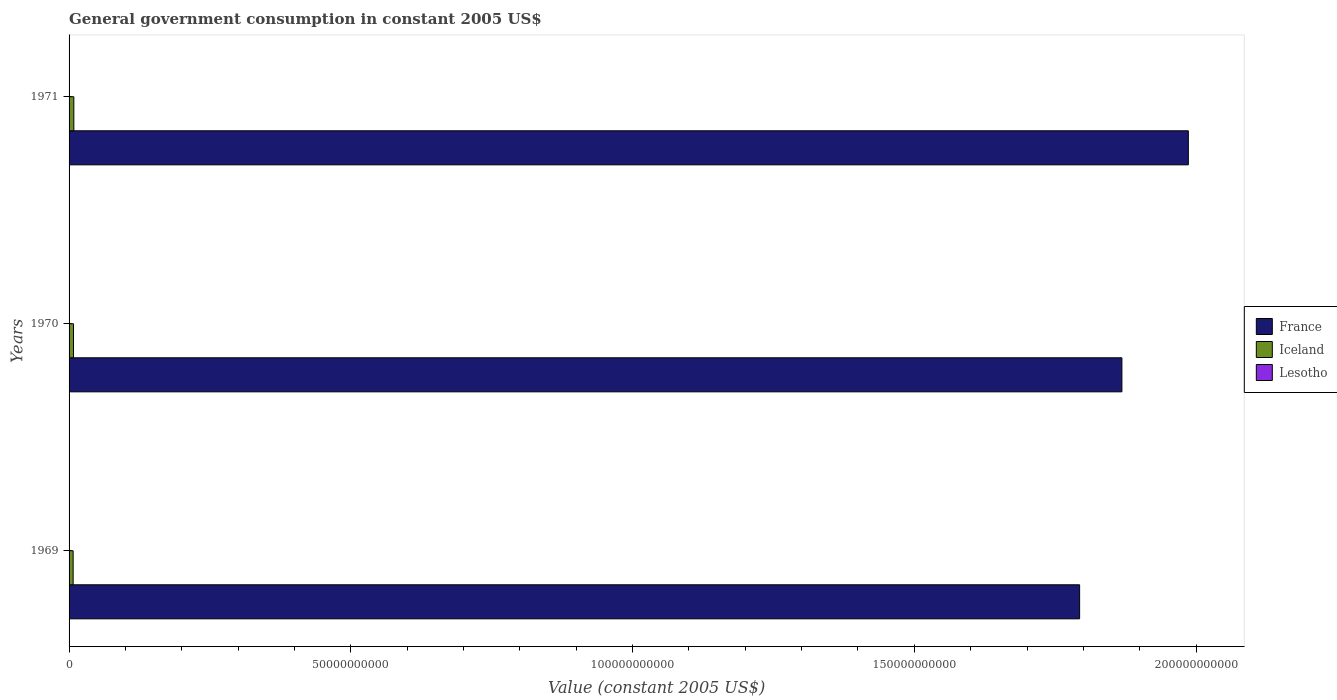How many different coloured bars are there?
Provide a succinct answer. 3. How many groups of bars are there?
Provide a short and direct response. 3. Are the number of bars on each tick of the Y-axis equal?
Provide a succinct answer. Yes. How many bars are there on the 3rd tick from the top?
Your answer should be very brief. 3. How many bars are there on the 3rd tick from the bottom?
Offer a very short reply. 3. What is the government conusmption in Iceland in 1970?
Keep it short and to the point. 7.87e+08. Across all years, what is the maximum government conusmption in Iceland?
Offer a very short reply. 8.47e+08. Across all years, what is the minimum government conusmption in Iceland?
Offer a terse response. 7.23e+08. In which year was the government conusmption in France minimum?
Make the answer very short. 1969. What is the total government conusmption in Lesotho in the graph?
Your answer should be compact. 1.54e+08. What is the difference between the government conusmption in Iceland in 1969 and that in 1970?
Make the answer very short. -6.38e+07. What is the difference between the government conusmption in Lesotho in 1970 and the government conusmption in Iceland in 1971?
Provide a succinct answer. -8.03e+08. What is the average government conusmption in Iceland per year?
Offer a very short reply. 7.86e+08. In the year 1969, what is the difference between the government conusmption in Iceland and government conusmption in Lesotho?
Your response must be concise. 6.79e+08. In how many years, is the government conusmption in France greater than 140000000000 US$?
Your answer should be very brief. 3. What is the ratio of the government conusmption in Lesotho in 1969 to that in 1970?
Give a very brief answer. 1.02. What is the difference between the highest and the second highest government conusmption in Iceland?
Keep it short and to the point. 5.99e+07. What is the difference between the highest and the lowest government conusmption in Lesotho?
Your response must be concise. 2.23e+07. In how many years, is the government conusmption in France greater than the average government conusmption in France taken over all years?
Your response must be concise. 1. Is the sum of the government conusmption in France in 1970 and 1971 greater than the maximum government conusmption in Iceland across all years?
Provide a succinct answer. Yes. What does the 2nd bar from the top in 1970 represents?
Give a very brief answer. Iceland. What does the 3rd bar from the bottom in 1969 represents?
Give a very brief answer. Lesotho. Is it the case that in every year, the sum of the government conusmption in Lesotho and government conusmption in France is greater than the government conusmption in Iceland?
Keep it short and to the point. Yes. How many bars are there?
Provide a short and direct response. 9. What is the difference between two consecutive major ticks on the X-axis?
Ensure brevity in your answer.  5.00e+1. Are the values on the major ticks of X-axis written in scientific E-notation?
Keep it short and to the point. No. Does the graph contain grids?
Provide a succinct answer. No. How many legend labels are there?
Your answer should be compact. 3. What is the title of the graph?
Provide a succinct answer. General government consumption in constant 2005 US$. What is the label or title of the X-axis?
Give a very brief answer. Value (constant 2005 US$). What is the Value (constant 2005 US$) in France in 1969?
Make the answer very short. 1.79e+11. What is the Value (constant 2005 US$) in Iceland in 1969?
Provide a short and direct response. 7.23e+08. What is the Value (constant 2005 US$) of Lesotho in 1969?
Offer a very short reply. 4.47e+07. What is the Value (constant 2005 US$) of France in 1970?
Provide a succinct answer. 1.87e+11. What is the Value (constant 2005 US$) in Iceland in 1970?
Provide a succinct answer. 7.87e+08. What is the Value (constant 2005 US$) of Lesotho in 1970?
Offer a very short reply. 4.37e+07. What is the Value (constant 2005 US$) of France in 1971?
Your answer should be very brief. 1.99e+11. What is the Value (constant 2005 US$) of Iceland in 1971?
Your response must be concise. 8.47e+08. What is the Value (constant 2005 US$) in Lesotho in 1971?
Keep it short and to the point. 6.60e+07. Across all years, what is the maximum Value (constant 2005 US$) in France?
Offer a very short reply. 1.99e+11. Across all years, what is the maximum Value (constant 2005 US$) of Iceland?
Offer a very short reply. 8.47e+08. Across all years, what is the maximum Value (constant 2005 US$) in Lesotho?
Offer a terse response. 6.60e+07. Across all years, what is the minimum Value (constant 2005 US$) in France?
Keep it short and to the point. 1.79e+11. Across all years, what is the minimum Value (constant 2005 US$) of Iceland?
Give a very brief answer. 7.23e+08. Across all years, what is the minimum Value (constant 2005 US$) in Lesotho?
Provide a succinct answer. 4.37e+07. What is the total Value (constant 2005 US$) in France in the graph?
Your response must be concise. 5.65e+11. What is the total Value (constant 2005 US$) in Iceland in the graph?
Offer a very short reply. 2.36e+09. What is the total Value (constant 2005 US$) in Lesotho in the graph?
Your answer should be compact. 1.54e+08. What is the difference between the Value (constant 2005 US$) of France in 1969 and that in 1970?
Keep it short and to the point. -7.50e+09. What is the difference between the Value (constant 2005 US$) in Iceland in 1969 and that in 1970?
Provide a succinct answer. -6.38e+07. What is the difference between the Value (constant 2005 US$) of Lesotho in 1969 and that in 1970?
Provide a succinct answer. 9.57e+05. What is the difference between the Value (constant 2005 US$) in France in 1969 and that in 1971?
Give a very brief answer. -1.93e+1. What is the difference between the Value (constant 2005 US$) in Iceland in 1969 and that in 1971?
Your answer should be compact. -1.24e+08. What is the difference between the Value (constant 2005 US$) in Lesotho in 1969 and that in 1971?
Keep it short and to the point. -2.13e+07. What is the difference between the Value (constant 2005 US$) of France in 1970 and that in 1971?
Your answer should be compact. -1.18e+1. What is the difference between the Value (constant 2005 US$) in Iceland in 1970 and that in 1971?
Keep it short and to the point. -5.99e+07. What is the difference between the Value (constant 2005 US$) of Lesotho in 1970 and that in 1971?
Provide a succinct answer. -2.23e+07. What is the difference between the Value (constant 2005 US$) of France in 1969 and the Value (constant 2005 US$) of Iceland in 1970?
Keep it short and to the point. 1.79e+11. What is the difference between the Value (constant 2005 US$) in France in 1969 and the Value (constant 2005 US$) in Lesotho in 1970?
Offer a terse response. 1.79e+11. What is the difference between the Value (constant 2005 US$) in Iceland in 1969 and the Value (constant 2005 US$) in Lesotho in 1970?
Give a very brief answer. 6.79e+08. What is the difference between the Value (constant 2005 US$) of France in 1969 and the Value (constant 2005 US$) of Iceland in 1971?
Offer a very short reply. 1.78e+11. What is the difference between the Value (constant 2005 US$) in France in 1969 and the Value (constant 2005 US$) in Lesotho in 1971?
Provide a short and direct response. 1.79e+11. What is the difference between the Value (constant 2005 US$) in Iceland in 1969 and the Value (constant 2005 US$) in Lesotho in 1971?
Make the answer very short. 6.57e+08. What is the difference between the Value (constant 2005 US$) of France in 1970 and the Value (constant 2005 US$) of Iceland in 1971?
Offer a terse response. 1.86e+11. What is the difference between the Value (constant 2005 US$) of France in 1970 and the Value (constant 2005 US$) of Lesotho in 1971?
Your answer should be very brief. 1.87e+11. What is the difference between the Value (constant 2005 US$) of Iceland in 1970 and the Value (constant 2005 US$) of Lesotho in 1971?
Ensure brevity in your answer.  7.21e+08. What is the average Value (constant 2005 US$) of France per year?
Keep it short and to the point. 1.88e+11. What is the average Value (constant 2005 US$) in Iceland per year?
Give a very brief answer. 7.86e+08. What is the average Value (constant 2005 US$) in Lesotho per year?
Offer a terse response. 5.15e+07. In the year 1969, what is the difference between the Value (constant 2005 US$) of France and Value (constant 2005 US$) of Iceland?
Your answer should be compact. 1.79e+11. In the year 1969, what is the difference between the Value (constant 2005 US$) in France and Value (constant 2005 US$) in Lesotho?
Provide a short and direct response. 1.79e+11. In the year 1969, what is the difference between the Value (constant 2005 US$) in Iceland and Value (constant 2005 US$) in Lesotho?
Your answer should be very brief. 6.79e+08. In the year 1970, what is the difference between the Value (constant 2005 US$) of France and Value (constant 2005 US$) of Iceland?
Your answer should be very brief. 1.86e+11. In the year 1970, what is the difference between the Value (constant 2005 US$) in France and Value (constant 2005 US$) in Lesotho?
Your response must be concise. 1.87e+11. In the year 1970, what is the difference between the Value (constant 2005 US$) of Iceland and Value (constant 2005 US$) of Lesotho?
Ensure brevity in your answer.  7.43e+08. In the year 1971, what is the difference between the Value (constant 2005 US$) of France and Value (constant 2005 US$) of Iceland?
Your response must be concise. 1.98e+11. In the year 1971, what is the difference between the Value (constant 2005 US$) in France and Value (constant 2005 US$) in Lesotho?
Provide a short and direct response. 1.99e+11. In the year 1971, what is the difference between the Value (constant 2005 US$) in Iceland and Value (constant 2005 US$) in Lesotho?
Your answer should be compact. 7.81e+08. What is the ratio of the Value (constant 2005 US$) in France in 1969 to that in 1970?
Your answer should be very brief. 0.96. What is the ratio of the Value (constant 2005 US$) of Iceland in 1969 to that in 1970?
Your answer should be very brief. 0.92. What is the ratio of the Value (constant 2005 US$) of Lesotho in 1969 to that in 1970?
Keep it short and to the point. 1.02. What is the ratio of the Value (constant 2005 US$) in France in 1969 to that in 1971?
Make the answer very short. 0.9. What is the ratio of the Value (constant 2005 US$) in Iceland in 1969 to that in 1971?
Your answer should be compact. 0.85. What is the ratio of the Value (constant 2005 US$) of Lesotho in 1969 to that in 1971?
Ensure brevity in your answer.  0.68. What is the ratio of the Value (constant 2005 US$) of France in 1970 to that in 1971?
Offer a very short reply. 0.94. What is the ratio of the Value (constant 2005 US$) in Iceland in 1970 to that in 1971?
Your response must be concise. 0.93. What is the ratio of the Value (constant 2005 US$) of Lesotho in 1970 to that in 1971?
Offer a terse response. 0.66. What is the difference between the highest and the second highest Value (constant 2005 US$) of France?
Ensure brevity in your answer.  1.18e+1. What is the difference between the highest and the second highest Value (constant 2005 US$) of Iceland?
Provide a short and direct response. 5.99e+07. What is the difference between the highest and the second highest Value (constant 2005 US$) of Lesotho?
Provide a succinct answer. 2.13e+07. What is the difference between the highest and the lowest Value (constant 2005 US$) of France?
Offer a very short reply. 1.93e+1. What is the difference between the highest and the lowest Value (constant 2005 US$) of Iceland?
Your response must be concise. 1.24e+08. What is the difference between the highest and the lowest Value (constant 2005 US$) in Lesotho?
Your answer should be very brief. 2.23e+07. 